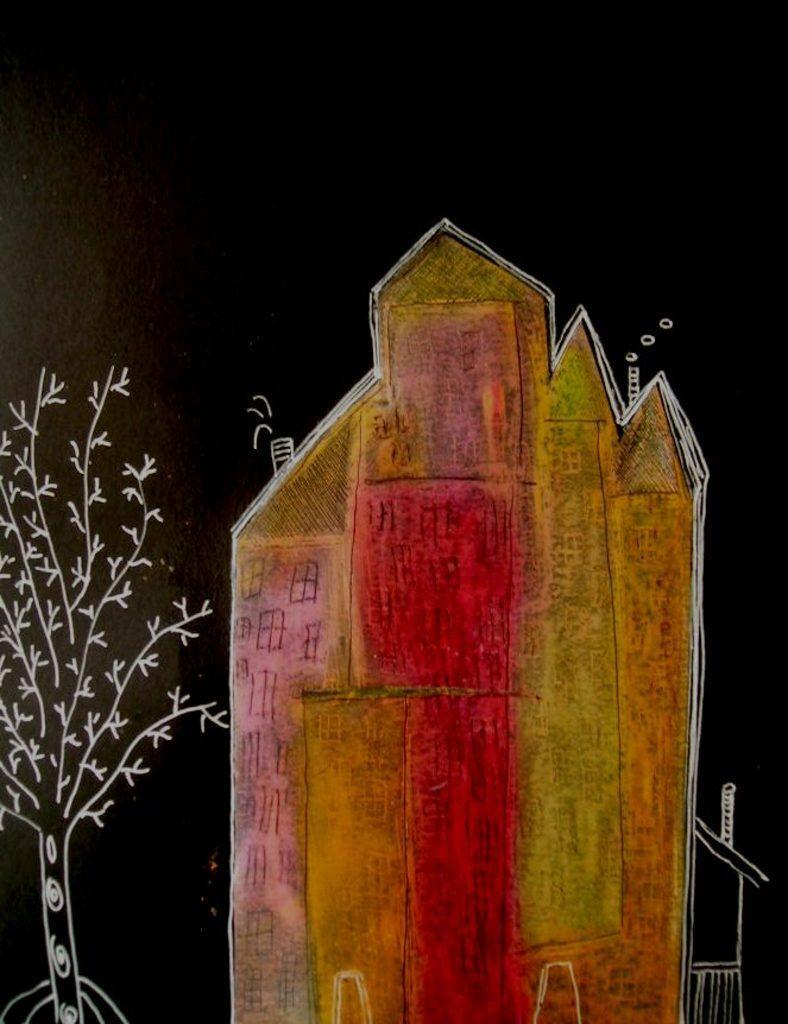Could you give a brief overview of what you see in this image? In this image we can see a sketch. In the sketch there are pictures of house and tree. 